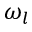<formula> <loc_0><loc_0><loc_500><loc_500>\omega _ { l }</formula> 